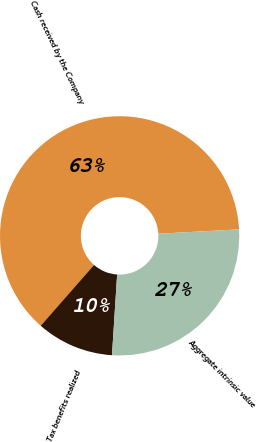Convert chart to OTSL. <chart><loc_0><loc_0><loc_500><loc_500><pie_chart><fcel>Cash received by the Company<fcel>Tax benefits realized<fcel>Aggregate intrinsic value<nl><fcel>62.67%<fcel>10.45%<fcel>26.88%<nl></chart> 